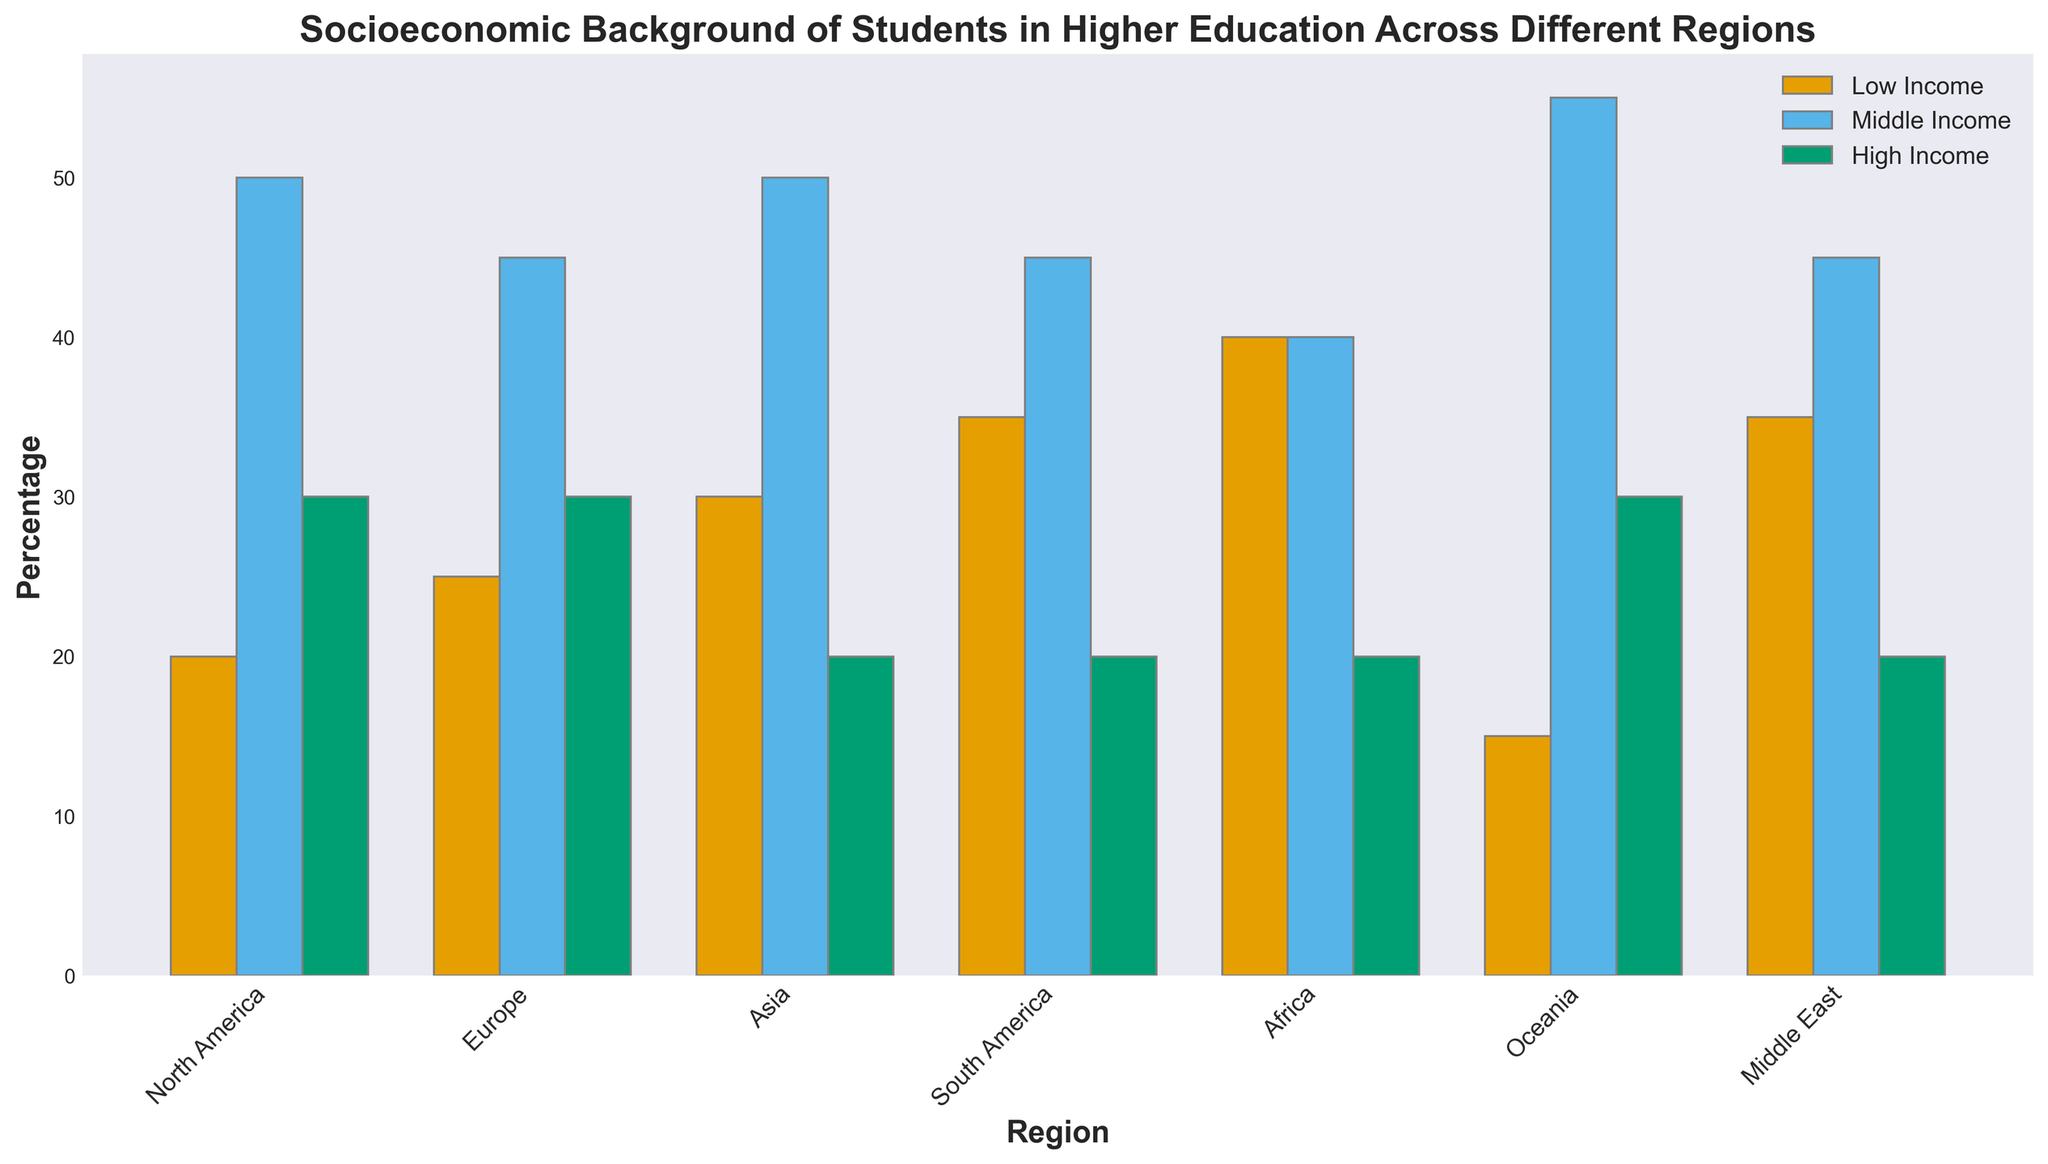What region has the highest percentage of low-income students? Check the bars corresponding to each region's low-income students. The tallest bar denotes the highest percentage. Africa has the tallest bar for low-income students.
Answer: Africa Which region has an equal percentage of middle-income and high-income students? Locate regions where the middle-income and high-income bars are of the same height. None of the regions shows equal percentages for these categories.
Answer: None What is the average percentage of low-income students in North America and Europe? Find and sum the percentages of low-income students in North America (20) and Europe (25), then divide by 2. (20 + 25) / 2 = 22.5
Answer: 22.5 Which region has the lowest percentage of high-income students? Check the heights of high-income bars for all regions and find the smallest one. Asia, South America, Africa, and Middle East all have a low-income percentage of 20, the smallest.
Answer: Asia, South America, Africa, Middle East Is the percentage of middle-income students higher in Oceania or South America? Compare the heights of the middle-income bars for Oceania (55) and South America (45). Oceania's bar is taller.
Answer: Oceania What is the total percentage of high-income students in all regions combined? Add the high-income percentages for all regions: 30 (North America) + 30 (Europe) + 20 (Asia) + 20 (South America) + 20 (Africa) + 30 (Oceania) + 20 (Middle East) = 170
Answer: 170 How much higher is the percentage of middle-income students in Europe than in Africa? Subtract Africa's middle-income percentage (40) from Europe's middle-income percentage (45). 45 - 40 = 5
Answer: 5 Which region's low-income student percentage is almost the same as the total of high-income students in North America, Europe, and South America combined? North America's high-income: 30, Europe's high-income: 30, South America's high-income: 20; Total: 30 + 30 + 20 = 80. No single region has a low-income percentage that adds up to this.
Answer: None What is the average percentage of middle-income students across all regions? Sum middle-income percentages and divide by the number of regions: (50+45+50+45+40+55+45) = 330, divided by 7 regions is 330/7 ≈ 47.14
Answer: 47.14 